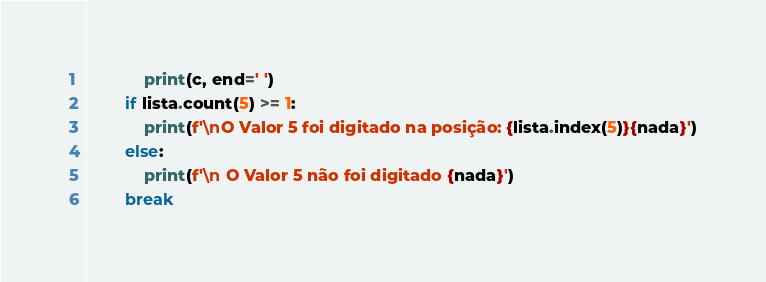Convert code to text. <code><loc_0><loc_0><loc_500><loc_500><_Python_>            print(c, end=' ')
        if lista.count(5) >= 1:
            print(f'\nO Valor 5 foi digitado na posição: {lista.index(5)}{nada}')
        else:
            print(f'\n O Valor 5 não foi digitado {nada}')
        break</code> 